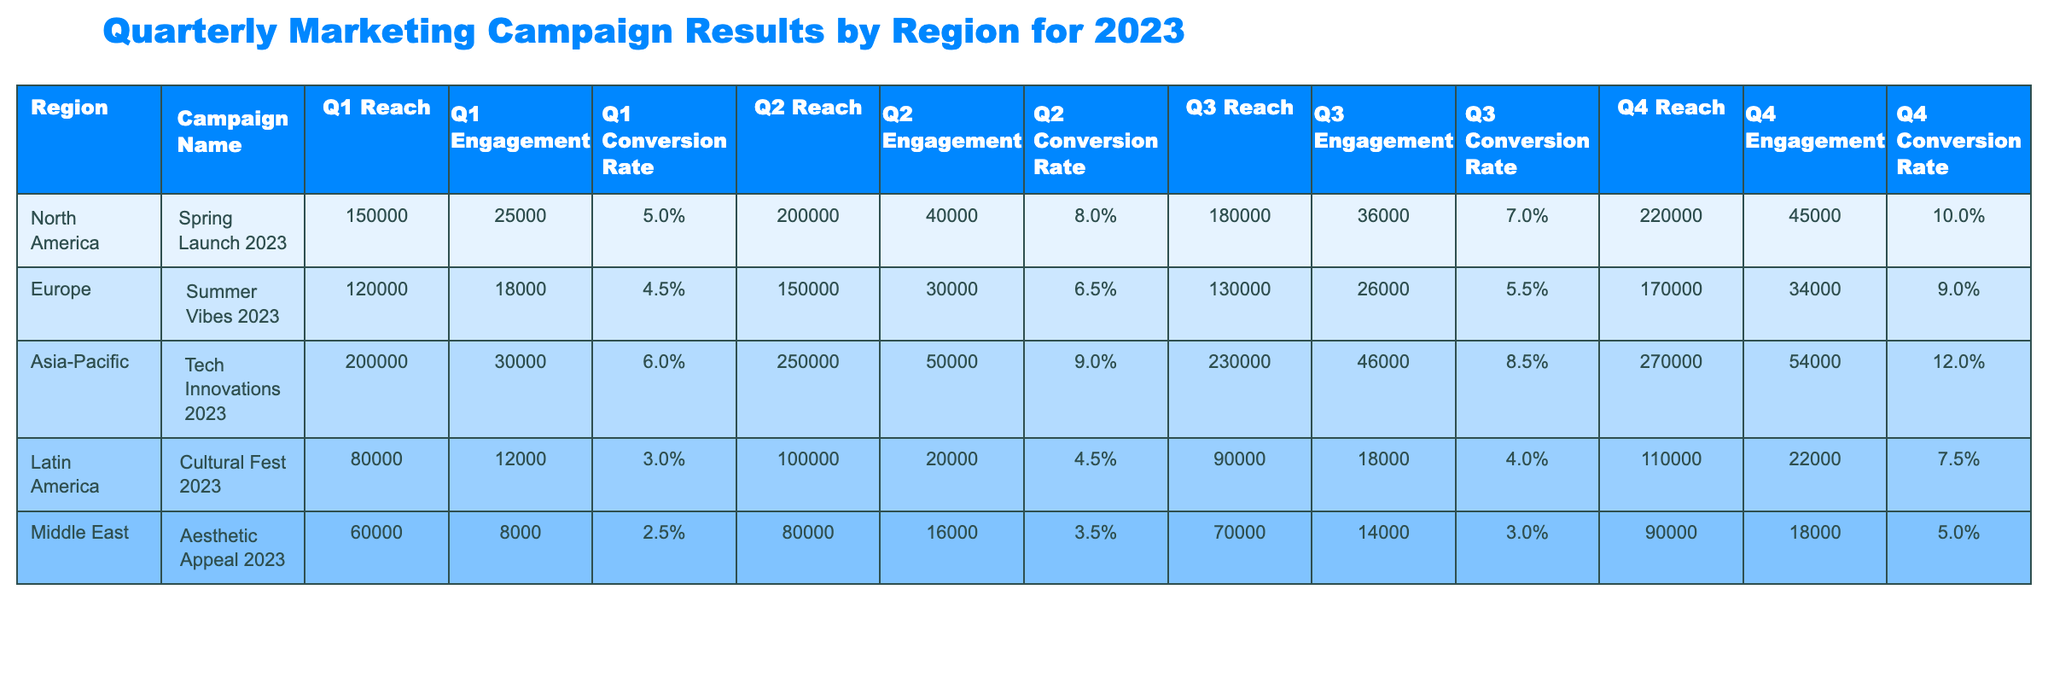What was the highest conversion rate achieved in Q3? By looking at the Q3 Conversion Rate column for each region, North America has a conversion rate of 7.0%, Europe 5.5%, Asia-Pacific 8.5%, Latin America 4.0%, and the Middle East 3.0%. The maximum value among these is 8.5%, which belongs to Asia-Pacific.
Answer: 8.5% What region had the highest reach in Q1? Checking the Q1 Reach column, North America reached 150000, Europe 120000, Asia-Pacific 200000, Latin America 80000, and the Middle East 60000. The highest value is 200000, from Asia-Pacific.
Answer: Asia-Pacific What is the average engagement across all regions in Q2? To find the average engagement in Q2, we take the engagements for each region: North America 40000, Europe 30000, Asia-Pacific 50000, Latin America 20000, and the Middle East 16000. Summing these gives 40000 + 30000 + 50000 + 20000 + 16000 = 156000. Dividing by the number of regions (5) gives 156000 / 5 = 31200.
Answer: 31200 Did the Middle East improve its conversion rate from Q1 to Q4? The conversion rates for the Middle East are 2.5% in Q1 and 5.0% in Q4. Comparing these values, we see an increase from 2.5% to 5.0%. Therefore, yes, the conversion rate improved.
Answer: Yes Which campaign had the highest overall reach across all quarters? We sum the reach for each campaign across all quarters. For the Spring Launch in North America: 150000 + 200000 + 180000 + 220000 = 750000. Summer Vibes in Europe: 120000 + 150000 + 130000 + 170000 = 570000. Tech Innovations in Asia-Pacific: 200000 + 250000 + 230000 + 270000 = 950000. Cultural Fest in Latin America: 80000 + 100000 + 90000 + 110000 = 380000. Aesthetic Appeal in the Middle East: 60000 + 80000 + 70000 + 90000 = 310000. The highest total is 950000, from Asia-Pacific's Tech Innovations.
Answer: Tech Innovations 